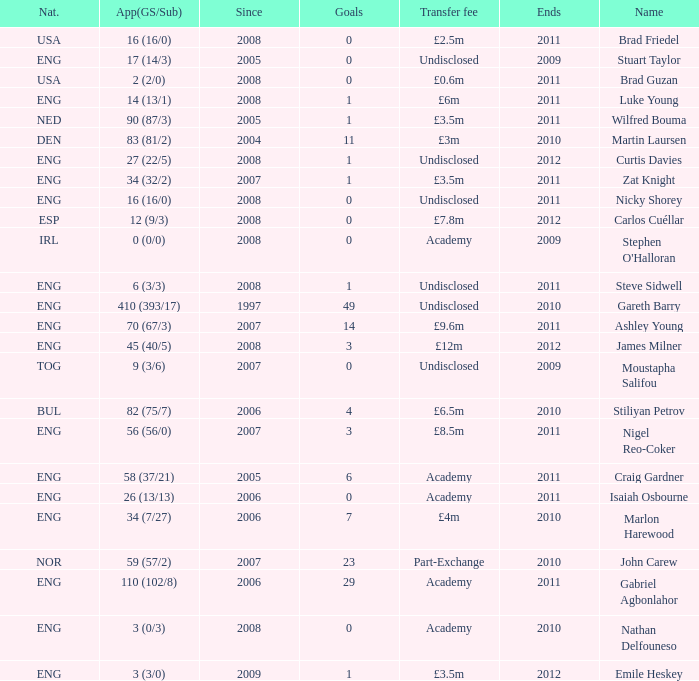What is the greatest goals for Curtis Davies if ends is greater than 2012? None. Could you parse the entire table? {'header': ['Nat.', 'App(GS/Sub)', 'Since', 'Goals', 'Transfer fee', 'Ends', 'Name'], 'rows': [['USA', '16 (16/0)', '2008', '0', '£2.5m', '2011', 'Brad Friedel'], ['ENG', '17 (14/3)', '2005', '0', 'Undisclosed', '2009', 'Stuart Taylor'], ['USA', '2 (2/0)', '2008', '0', '£0.6m', '2011', 'Brad Guzan'], ['ENG', '14 (13/1)', '2008', '1', '£6m', '2011', 'Luke Young'], ['NED', '90 (87/3)', '2005', '1', '£3.5m', '2011', 'Wilfred Bouma'], ['DEN', '83 (81/2)', '2004', '11', '£3m', '2010', 'Martin Laursen'], ['ENG', '27 (22/5)', '2008', '1', 'Undisclosed', '2012', 'Curtis Davies'], ['ENG', '34 (32/2)', '2007', '1', '£3.5m', '2011', 'Zat Knight'], ['ENG', '16 (16/0)', '2008', '0', 'Undisclosed', '2011', 'Nicky Shorey'], ['ESP', '12 (9/3)', '2008', '0', '£7.8m', '2012', 'Carlos Cuéllar'], ['IRL', '0 (0/0)', '2008', '0', 'Academy', '2009', "Stephen O'Halloran"], ['ENG', '6 (3/3)', '2008', '1', 'Undisclosed', '2011', 'Steve Sidwell'], ['ENG', '410 (393/17)', '1997', '49', 'Undisclosed', '2010', 'Gareth Barry'], ['ENG', '70 (67/3)', '2007', '14', '£9.6m', '2011', 'Ashley Young'], ['ENG', '45 (40/5)', '2008', '3', '£12m', '2012', 'James Milner'], ['TOG', '9 (3/6)', '2007', '0', 'Undisclosed', '2009', 'Moustapha Salifou'], ['BUL', '82 (75/7)', '2006', '4', '£6.5m', '2010', 'Stiliyan Petrov'], ['ENG', '56 (56/0)', '2007', '3', '£8.5m', '2011', 'Nigel Reo-Coker'], ['ENG', '58 (37/21)', '2005', '6', 'Academy', '2011', 'Craig Gardner'], ['ENG', '26 (13/13)', '2006', '0', 'Academy', '2011', 'Isaiah Osbourne'], ['ENG', '34 (7/27)', '2006', '7', '£4m', '2010', 'Marlon Harewood'], ['NOR', '59 (57/2)', '2007', '23', 'Part-Exchange', '2010', 'John Carew'], ['ENG', '110 (102/8)', '2006', '29', 'Academy', '2011', 'Gabriel Agbonlahor'], ['ENG', '3 (0/3)', '2008', '0', 'Academy', '2010', 'Nathan Delfouneso'], ['ENG', '3 (3/0)', '2009', '1', '£3.5m', '2012', 'Emile Heskey']]} 